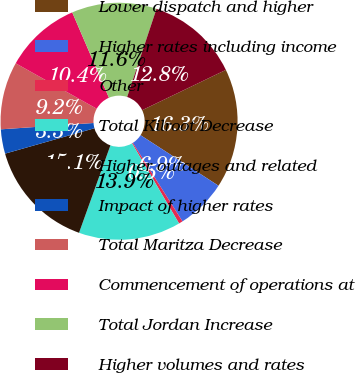Convert chart to OTSL. <chart><loc_0><loc_0><loc_500><loc_500><pie_chart><fcel>Lower dispatch and higher<fcel>Higher rates including income<fcel>Other<fcel>Total Kilroot Decrease<fcel>Higher outages and related<fcel>Impact of higher rates<fcel>Total Maritza Decrease<fcel>Commencement of operations at<fcel>Total Jordan Increase<fcel>Higher volumes and rates<nl><fcel>16.29%<fcel>6.86%<fcel>0.54%<fcel>13.93%<fcel>15.11%<fcel>3.32%<fcel>9.22%<fcel>10.4%<fcel>11.58%<fcel>12.75%<nl></chart> 